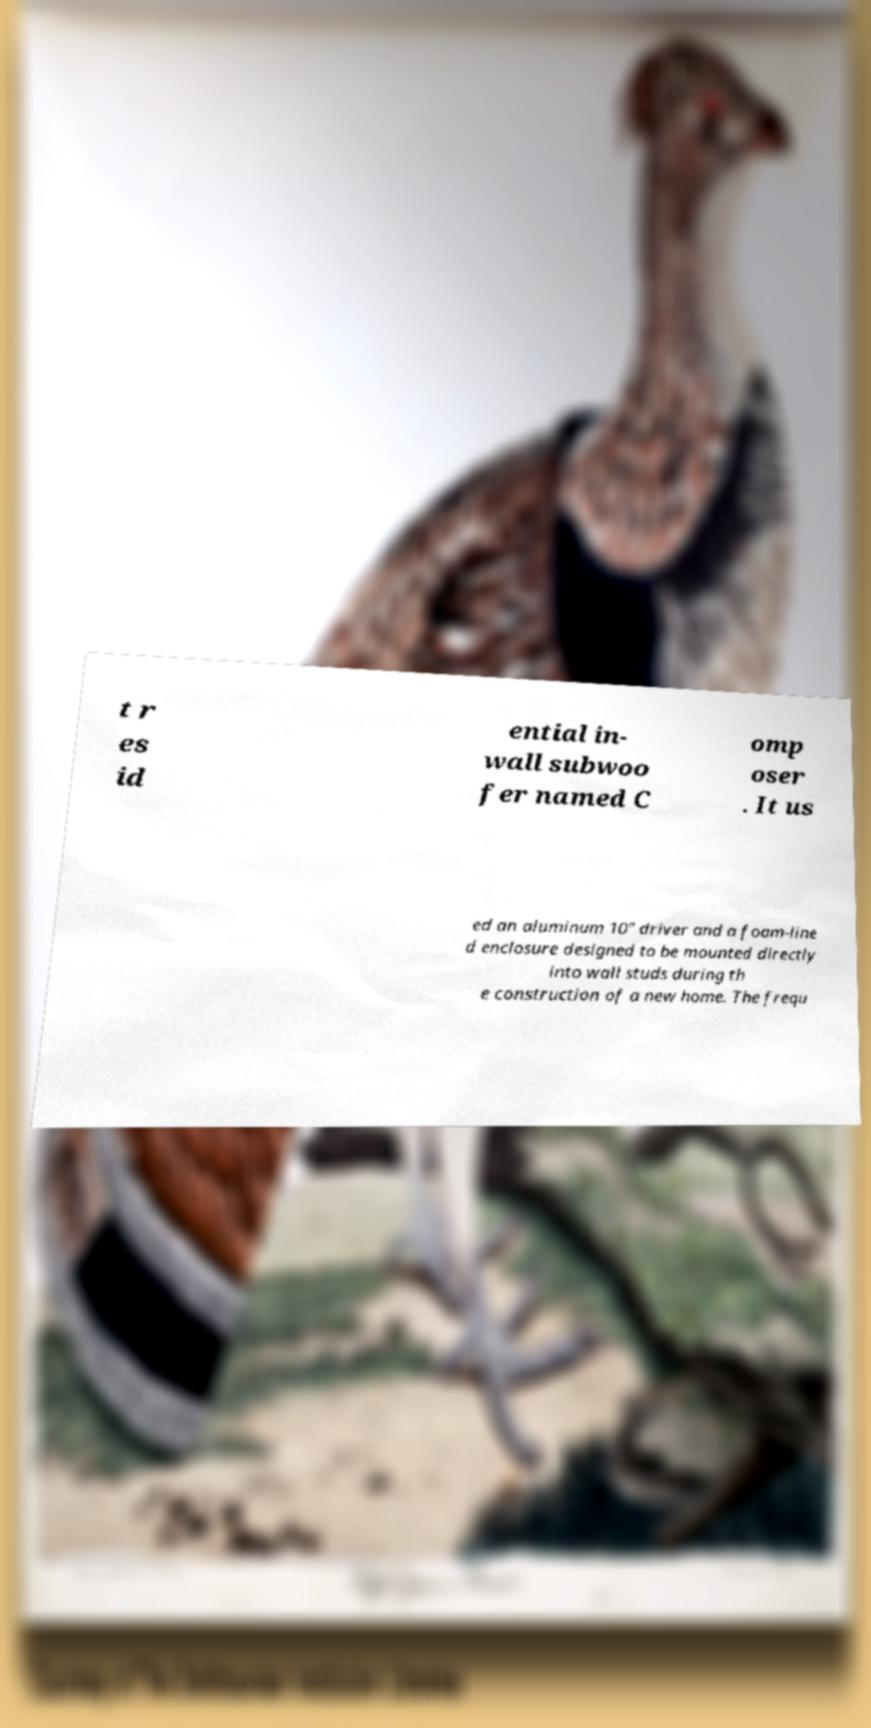Could you assist in decoding the text presented in this image and type it out clearly? t r es id ential in- wall subwoo fer named C omp oser . It us ed an aluminum 10" driver and a foam-line d enclosure designed to be mounted directly into wall studs during th e construction of a new home. The frequ 